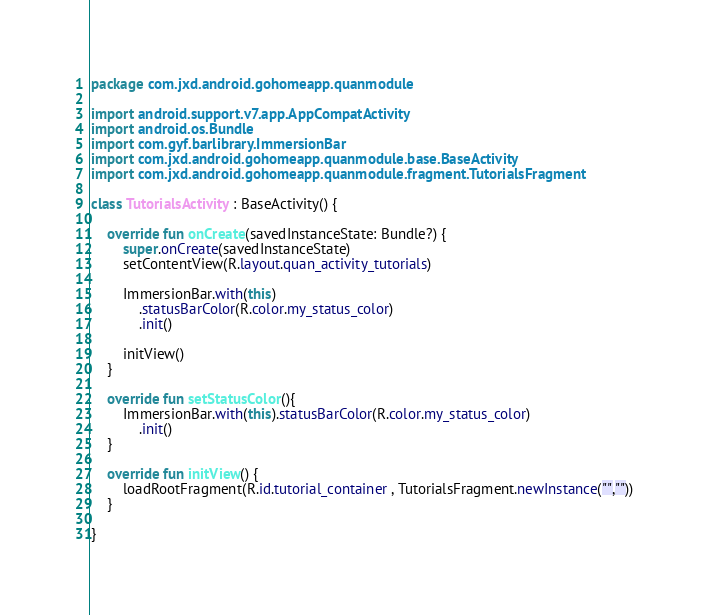Convert code to text. <code><loc_0><loc_0><loc_500><loc_500><_Kotlin_>package com.jxd.android.gohomeapp.quanmodule

import android.support.v7.app.AppCompatActivity
import android.os.Bundle
import com.gyf.barlibrary.ImmersionBar
import com.jxd.android.gohomeapp.quanmodule.base.BaseActivity
import com.jxd.android.gohomeapp.quanmodule.fragment.TutorialsFragment

class TutorialsActivity : BaseActivity() {

    override fun onCreate(savedInstanceState: Bundle?) {
        super.onCreate(savedInstanceState)
        setContentView(R.layout.quan_activity_tutorials)

        ImmersionBar.with(this)
            .statusBarColor(R.color.my_status_color)
            .init()

        initView()
    }

    override fun setStatusColor(){
        ImmersionBar.with(this).statusBarColor(R.color.my_status_color)
            .init()
    }

    override fun initView() {
        loadRootFragment(R.id.tutorial_container , TutorialsFragment.newInstance("",""))
    }

}
</code> 